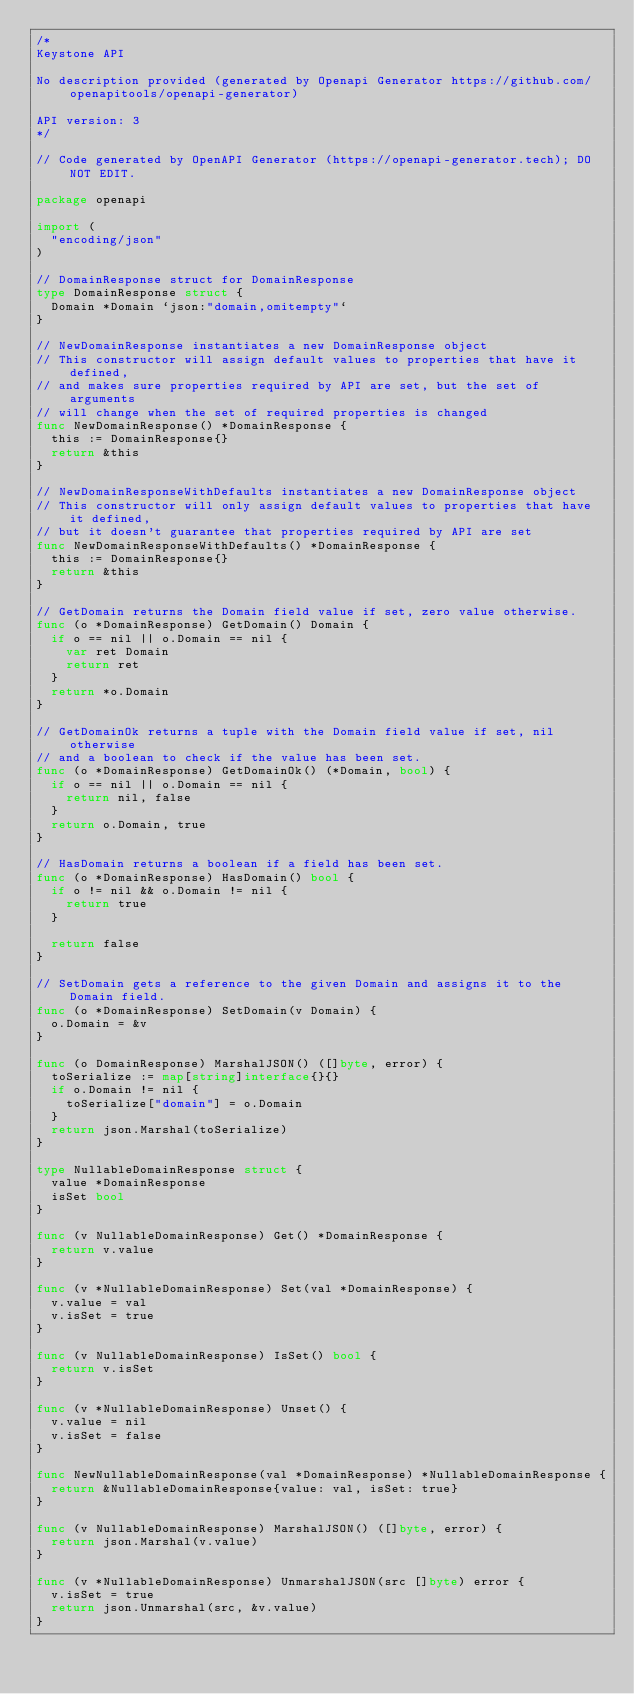<code> <loc_0><loc_0><loc_500><loc_500><_Go_>/*
Keystone API

No description provided (generated by Openapi Generator https://github.com/openapitools/openapi-generator)

API version: 3
*/

// Code generated by OpenAPI Generator (https://openapi-generator.tech); DO NOT EDIT.

package openapi

import (
	"encoding/json"
)

// DomainResponse struct for DomainResponse
type DomainResponse struct {
	Domain *Domain `json:"domain,omitempty"`
}

// NewDomainResponse instantiates a new DomainResponse object
// This constructor will assign default values to properties that have it defined,
// and makes sure properties required by API are set, but the set of arguments
// will change when the set of required properties is changed
func NewDomainResponse() *DomainResponse {
	this := DomainResponse{}
	return &this
}

// NewDomainResponseWithDefaults instantiates a new DomainResponse object
// This constructor will only assign default values to properties that have it defined,
// but it doesn't guarantee that properties required by API are set
func NewDomainResponseWithDefaults() *DomainResponse {
	this := DomainResponse{}
	return &this
}

// GetDomain returns the Domain field value if set, zero value otherwise.
func (o *DomainResponse) GetDomain() Domain {
	if o == nil || o.Domain == nil {
		var ret Domain
		return ret
	}
	return *o.Domain
}

// GetDomainOk returns a tuple with the Domain field value if set, nil otherwise
// and a boolean to check if the value has been set.
func (o *DomainResponse) GetDomainOk() (*Domain, bool) {
	if o == nil || o.Domain == nil {
		return nil, false
	}
	return o.Domain, true
}

// HasDomain returns a boolean if a field has been set.
func (o *DomainResponse) HasDomain() bool {
	if o != nil && o.Domain != nil {
		return true
	}

	return false
}

// SetDomain gets a reference to the given Domain and assigns it to the Domain field.
func (o *DomainResponse) SetDomain(v Domain) {
	o.Domain = &v
}

func (o DomainResponse) MarshalJSON() ([]byte, error) {
	toSerialize := map[string]interface{}{}
	if o.Domain != nil {
		toSerialize["domain"] = o.Domain
	}
	return json.Marshal(toSerialize)
}

type NullableDomainResponse struct {
	value *DomainResponse
	isSet bool
}

func (v NullableDomainResponse) Get() *DomainResponse {
	return v.value
}

func (v *NullableDomainResponse) Set(val *DomainResponse) {
	v.value = val
	v.isSet = true
}

func (v NullableDomainResponse) IsSet() bool {
	return v.isSet
}

func (v *NullableDomainResponse) Unset() {
	v.value = nil
	v.isSet = false
}

func NewNullableDomainResponse(val *DomainResponse) *NullableDomainResponse {
	return &NullableDomainResponse{value: val, isSet: true}
}

func (v NullableDomainResponse) MarshalJSON() ([]byte, error) {
	return json.Marshal(v.value)
}

func (v *NullableDomainResponse) UnmarshalJSON(src []byte) error {
	v.isSet = true
	return json.Unmarshal(src, &v.value)
}
</code> 